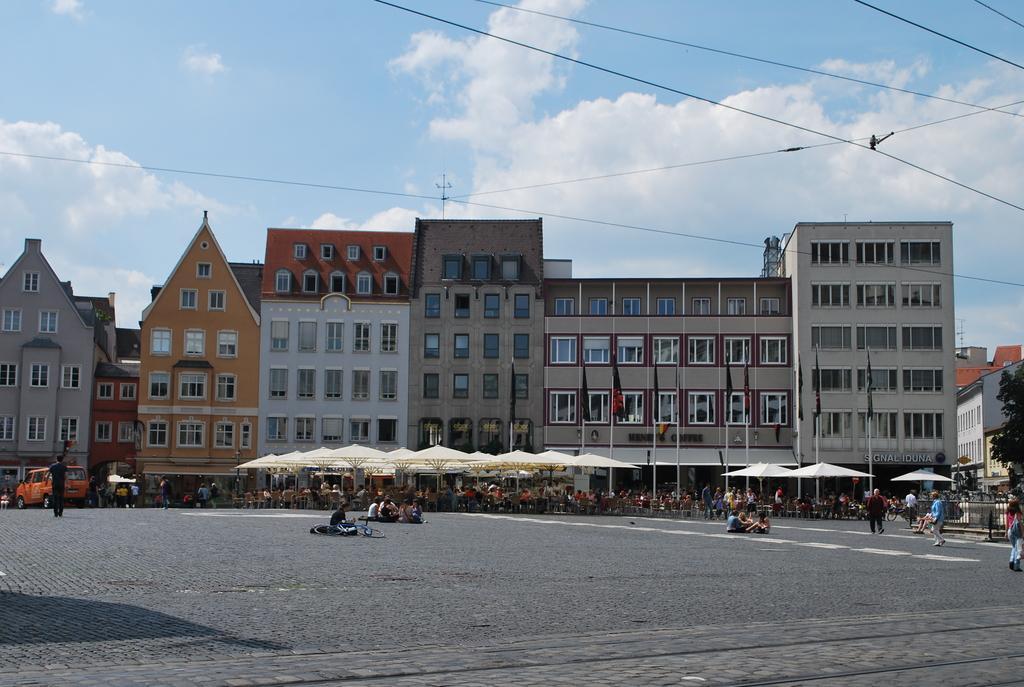Describe this image in one or two sentences. In this image on the road there are many people. Here under the shelter there are many people sitting on chairs. There are many tables over here. In the background there are buildings, flags. Here there are vehicles. This is a tree. The sky is cloudy. 